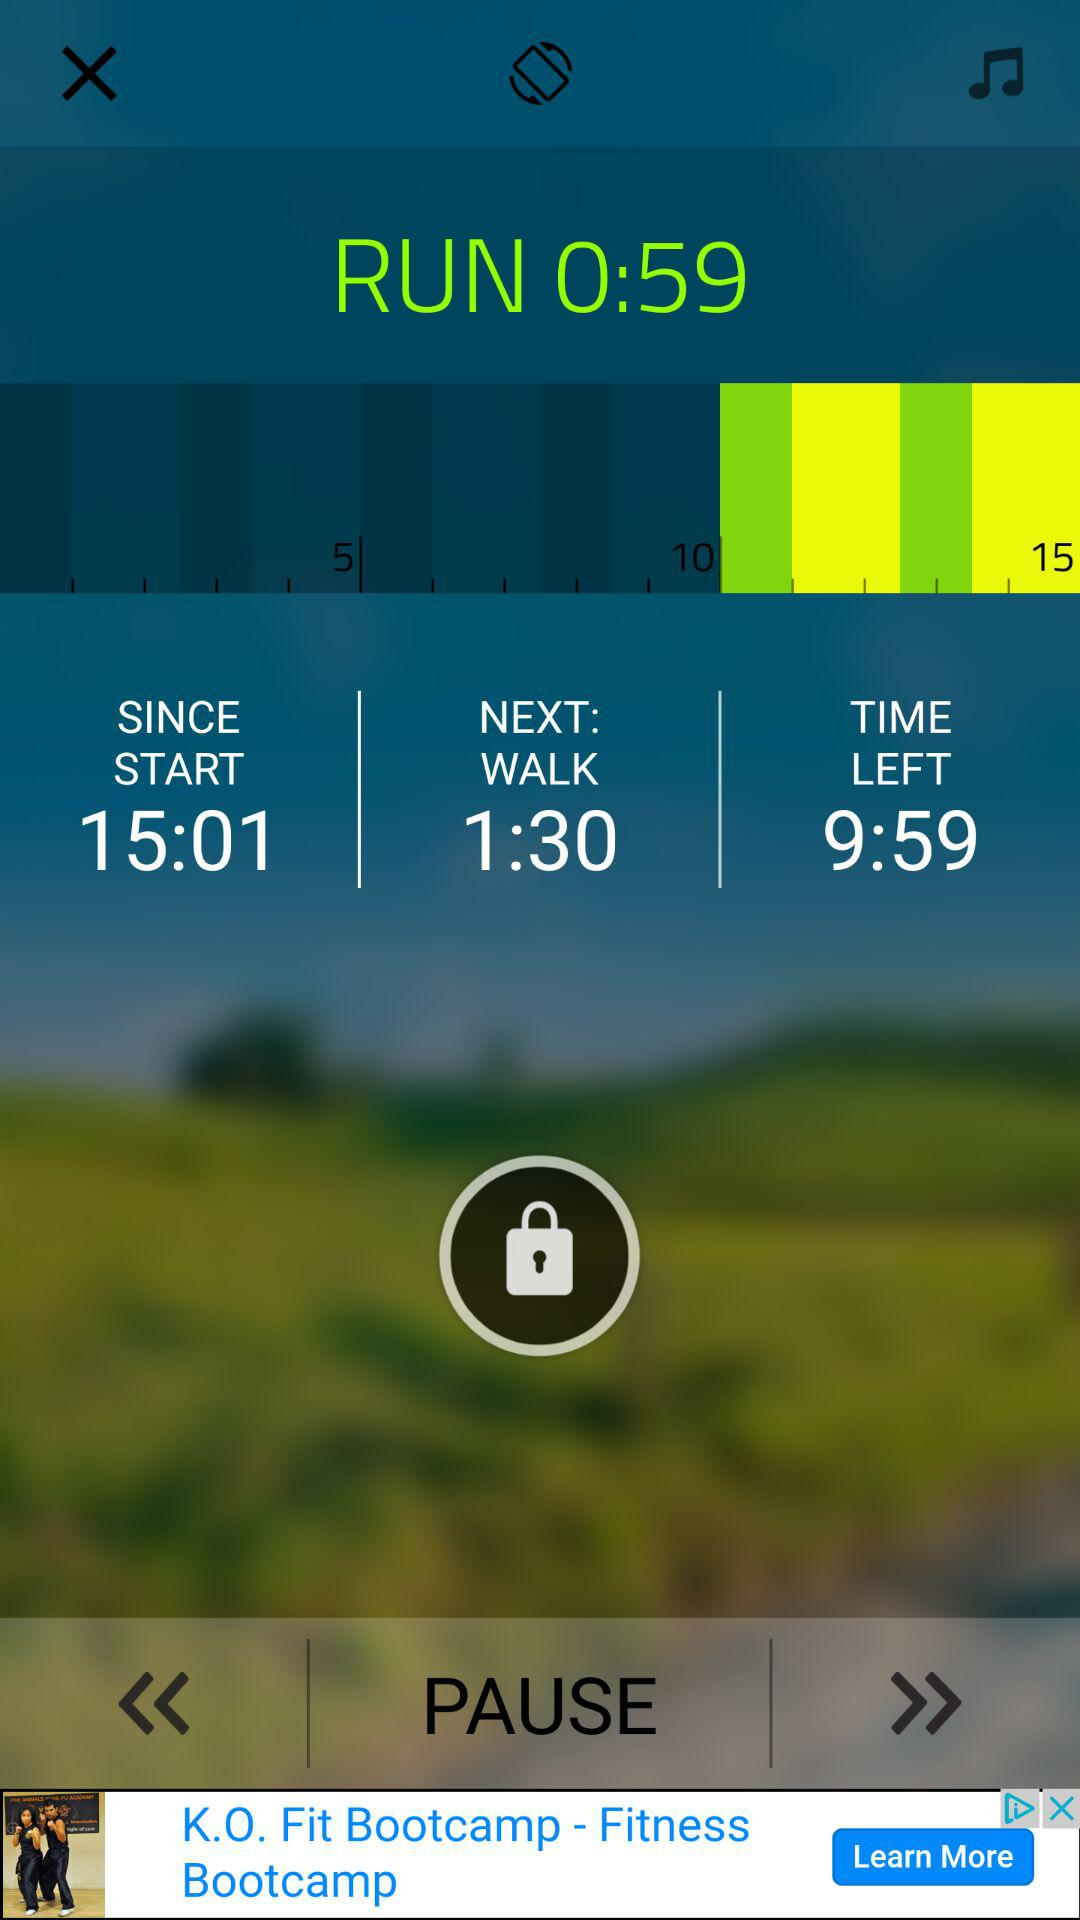How much time is left? The left time is 9 minutes and 59 seconds. 